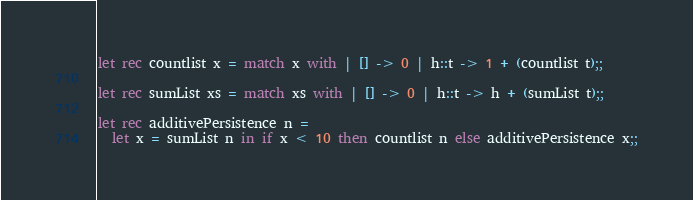Convert code to text. <code><loc_0><loc_0><loc_500><loc_500><_OCaml_>
let rec countlist x = match x with | [] -> 0 | h::t -> 1 + (countlist t);;

let rec sumList xs = match xs with | [] -> 0 | h::t -> h + (sumList t);;

let rec additivePersistence n =
  let x = sumList n in if x < 10 then countlist n else additivePersistence x;;
</code> 